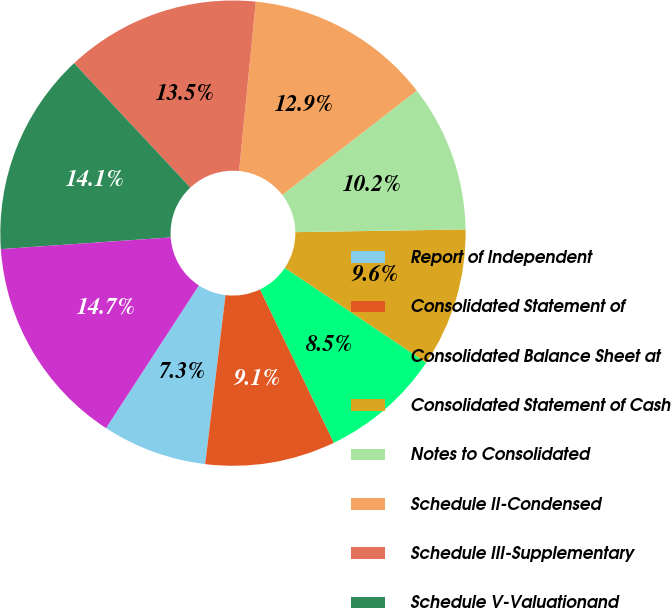<chart> <loc_0><loc_0><loc_500><loc_500><pie_chart><fcel>Report of Independent<fcel>Consolidated Statement of<fcel>Consolidated Balance Sheet at<fcel>Consolidated Statement of Cash<fcel>Notes to Consolidated<fcel>Schedule II-Condensed<fcel>Schedule III-Supplementary<fcel>Schedule V-Valuationand<fcel>Schedule VI-Supplementary<nl><fcel>7.28%<fcel>9.05%<fcel>8.46%<fcel>9.65%<fcel>10.24%<fcel>12.94%<fcel>13.53%<fcel>14.13%<fcel>14.72%<nl></chart> 